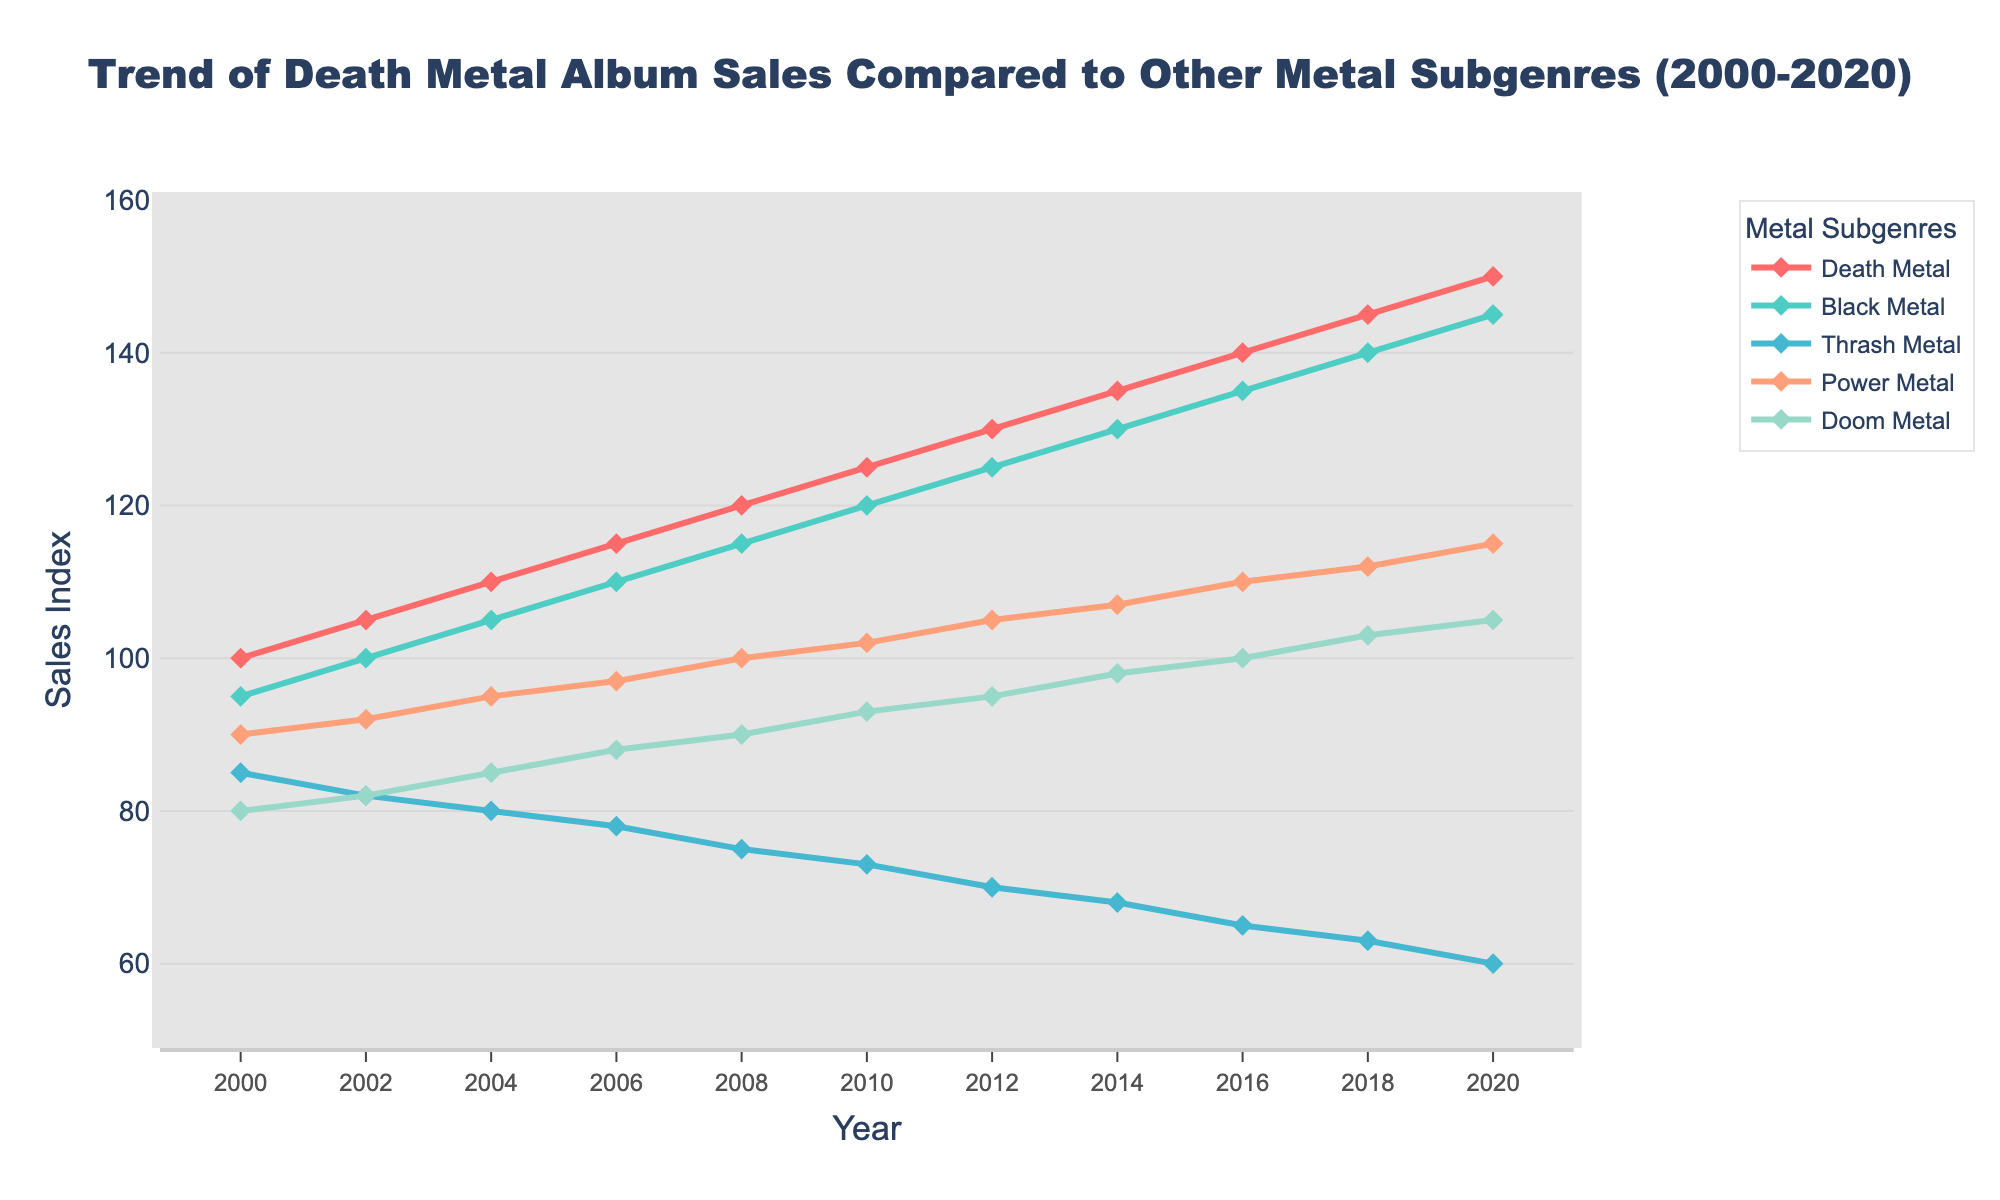What is the overall trend of Death Metal album sales between 2000 and 2020? The Death Metal album sales increase consistently from 100 in 2000 to 150 in 2020. Each year shows a steady rise in sales figures.
Answer: Increasing How did Black Metal and Doom Metal album sales compare in 2010? In 2010, Black Metal album sales were at 120, while Doom Metal sales were at 93. So, Black Metal sales were higher than Doom Metal sales.
Answer: Black Metal sales were higher than Doom Metal sales Which year did Thrash Metal album sales first drop below 70? By observing the chart for Thrash Metal, it first drops below 70 in the year 2012 when it registered a sales value of 70.
Answer: 2012 What is the average sales index of Power Metal from 2000 to 2020? The sales index for Power Metal over the years are: 90, 92, 95, 97, 100, 102, 105, 107, 110, 112, 115. Summing these values gives 1127, and dividing by the number of data points (11), we get an average of approximately 102.45.
Answer: 102.45 In which year did Death Metal sales exceed 130 for the first time? Looking at the line graph for Death Metal, we find that sales first exceed 130 in the year 2014 when the sales index hits 135.
Answer: 2014 Compare the sales trends of Power Metal and Doom Metal between 2012 and 2020. From 2012 to 2020, both Power Metal and Doom Metal show an increasing trend. Power Metal goes from 105 to 115, and Doom Metal goes from 95 to 105. Both increase consistently, but Power Metal ends at a higher sales index than Doom Metal.
Answer: Both increased, but Power Metal ends higher What was the difference in sales index between Black Metal and Thrash Metal in 2020? In 2020, Black Metal has a sales index of 145, while Thrash Metal has a value of 60. The difference between them is 145 - 60 = 85.
Answer: 85 Which subgenre had the least growth in sales from 2000 to 2020? To determine the least growth, we compare the start and end values for each genre: 
- Death Metal: 50 (150-100)
- Black Metal: 50 (145-95)
- Thrash Metal: -25 (60-85)
- Power Metal: 25 (115-90)
- Doom Metal: 25 (105-80)
Thrash Metal shows a decline, which is the least change.
Answer: Thrash Metal By how much did Doom Metal sales increase from 2000 to 2010? Doom Metal sales in 2000 were 80, and in 2010 they were 93. The increase is calculated as 93 - 80 = 13.
Answer: 13 Which year achieved the greatest increase in Death Metal album sales compared to the previous year? Looking at the data, Death Metal sales increased as follows for each period: 2000-2002: 5, 2002-2004: 5, 2004-2006: 5, 2006-2008: 5, 2008-2010: 5, 2010-2012: 5, 2012-2014: 5, 2014-2016: 5, 2016-2018: 5, 2018-2020: 5. Each period has the same increase of 5. So, in no year was the increase greater than any other year.
Answer: None 